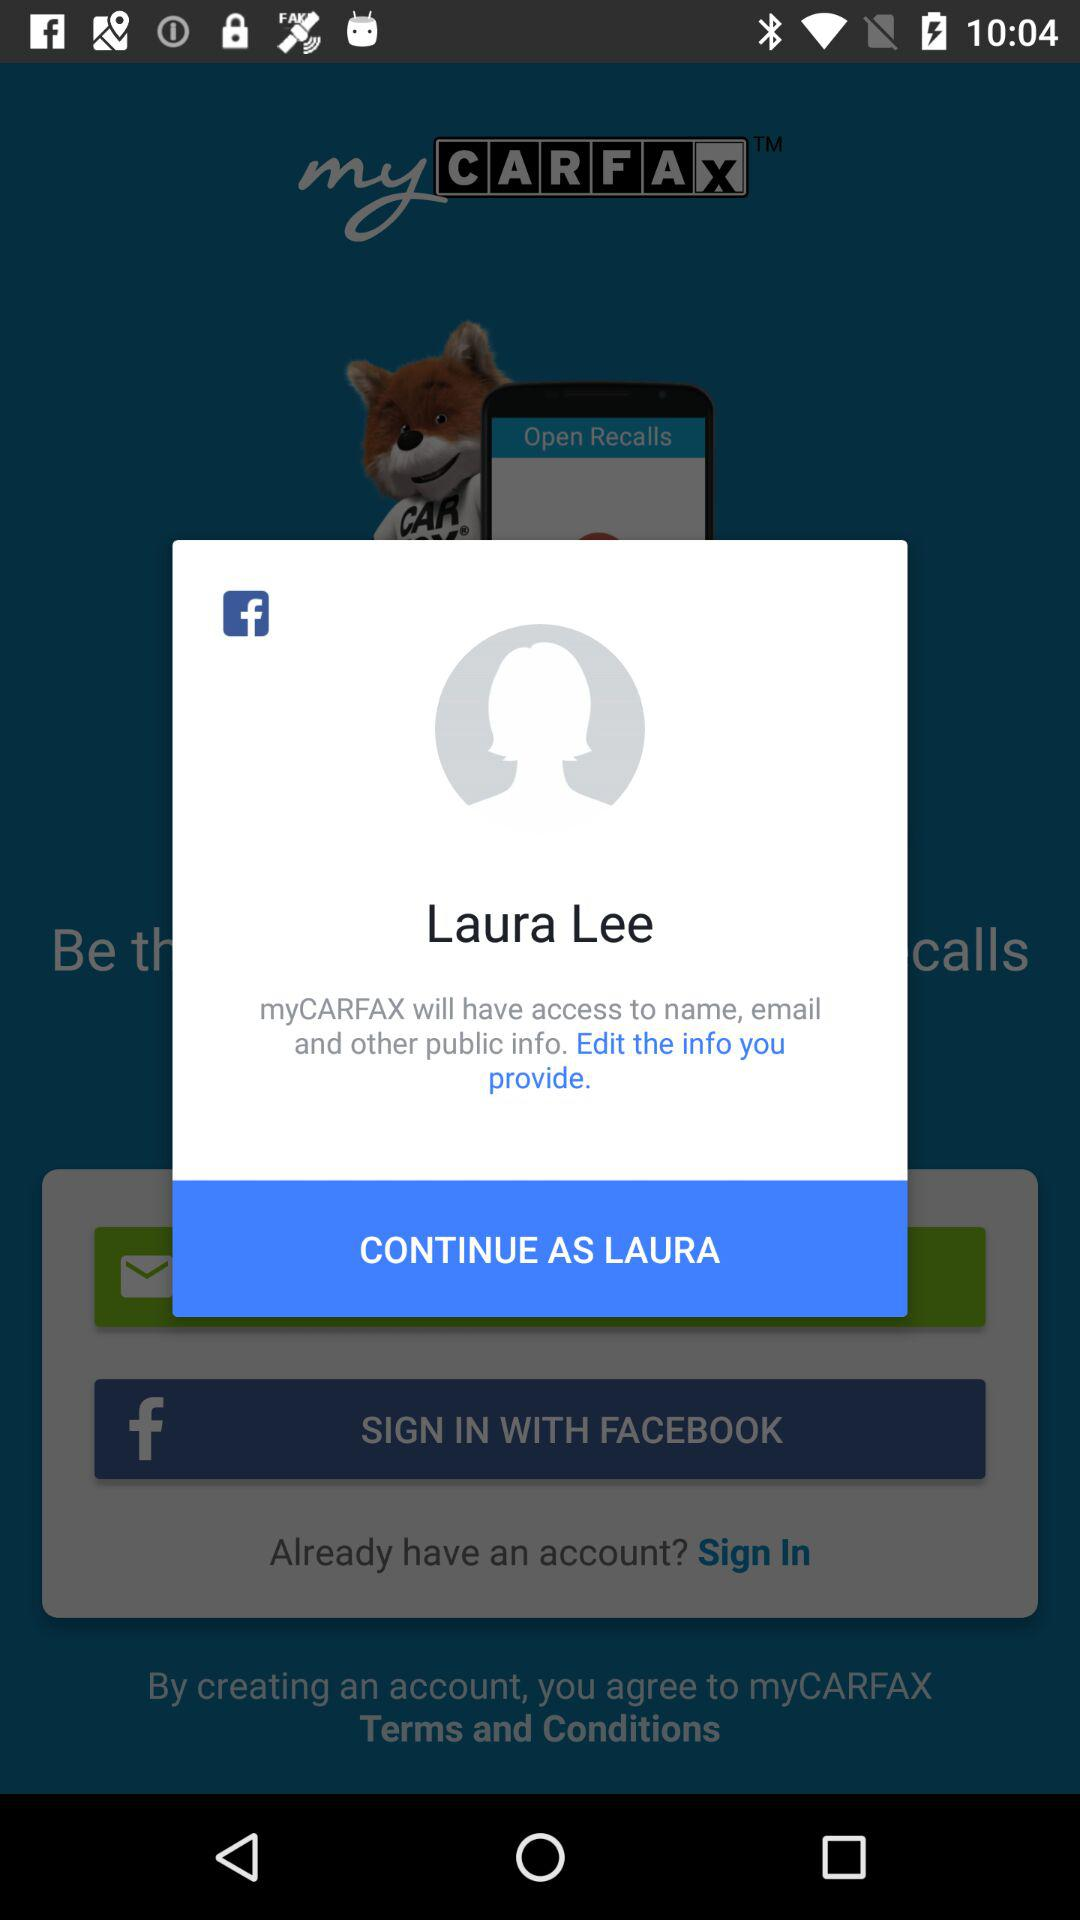What is the name of the user? The name of the user is Laura Lee. 